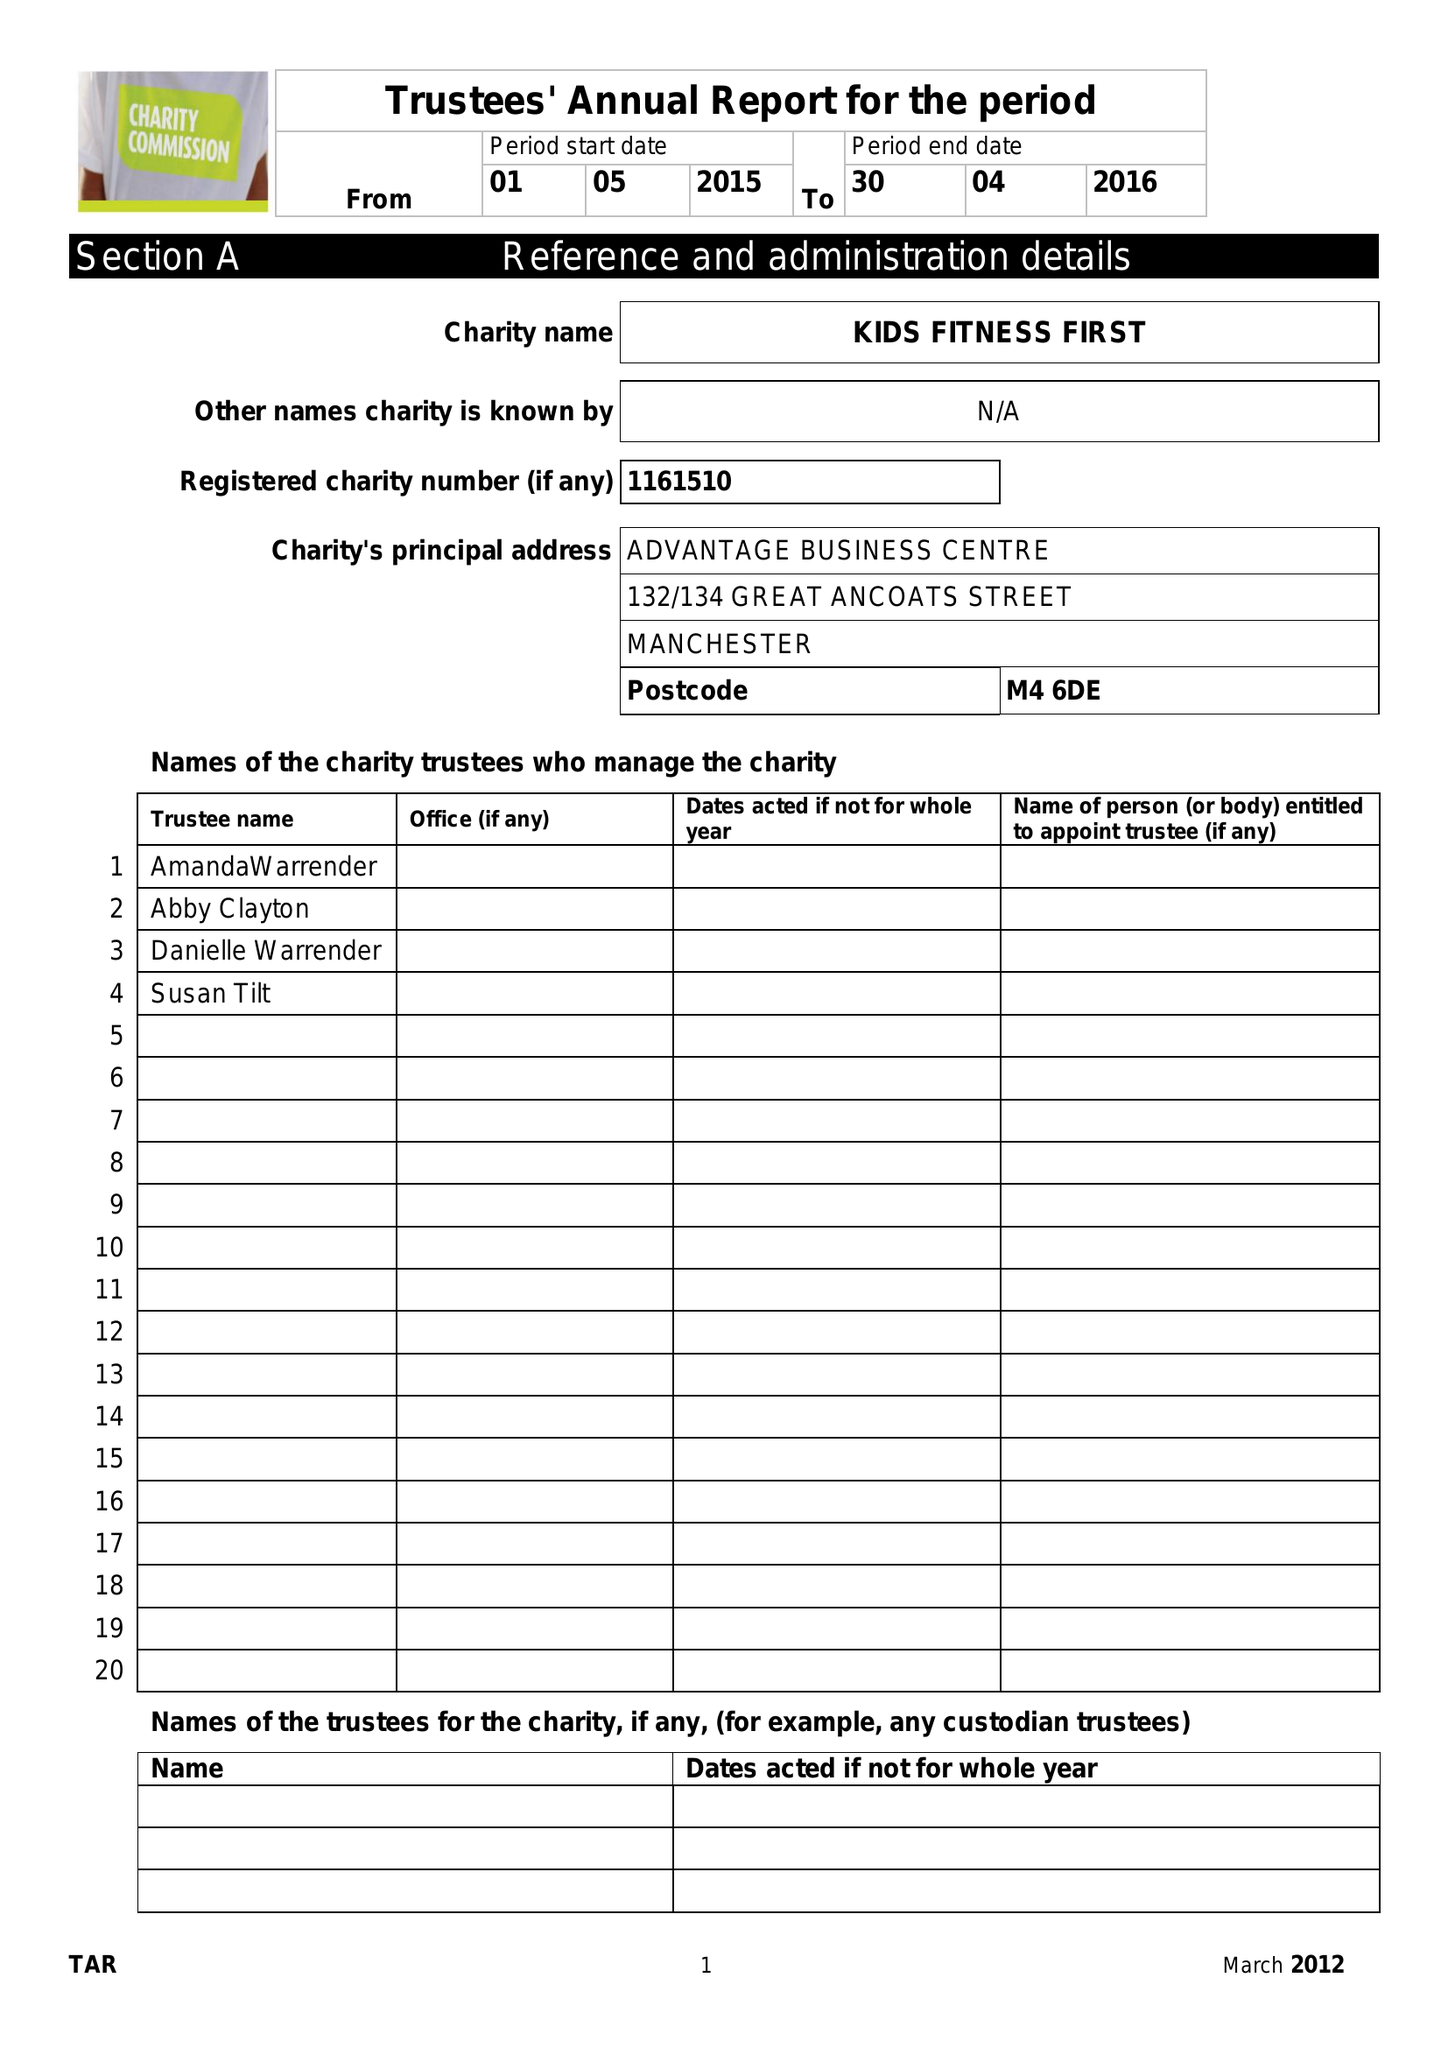What is the value for the spending_annually_in_british_pounds?
Answer the question using a single word or phrase. None 